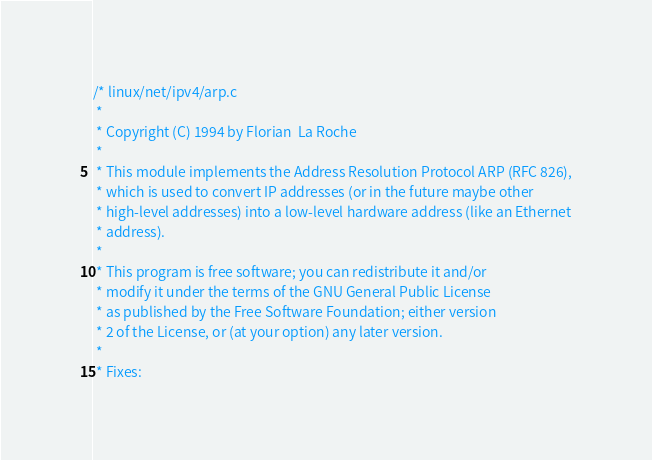<code> <loc_0><loc_0><loc_500><loc_500><_C_>/* linux/net/ipv4/arp.c
 *
 * Copyright (C) 1994 by Florian  La Roche
 *
 * This module implements the Address Resolution Protocol ARP (RFC 826),
 * which is used to convert IP addresses (or in the future maybe other
 * high-level addresses) into a low-level hardware address (like an Ethernet
 * address).
 *
 * This program is free software; you can redistribute it and/or
 * modify it under the terms of the GNU General Public License
 * as published by the Free Software Foundation; either version
 * 2 of the License, or (at your option) any later version.
 *
 * Fixes:</code> 